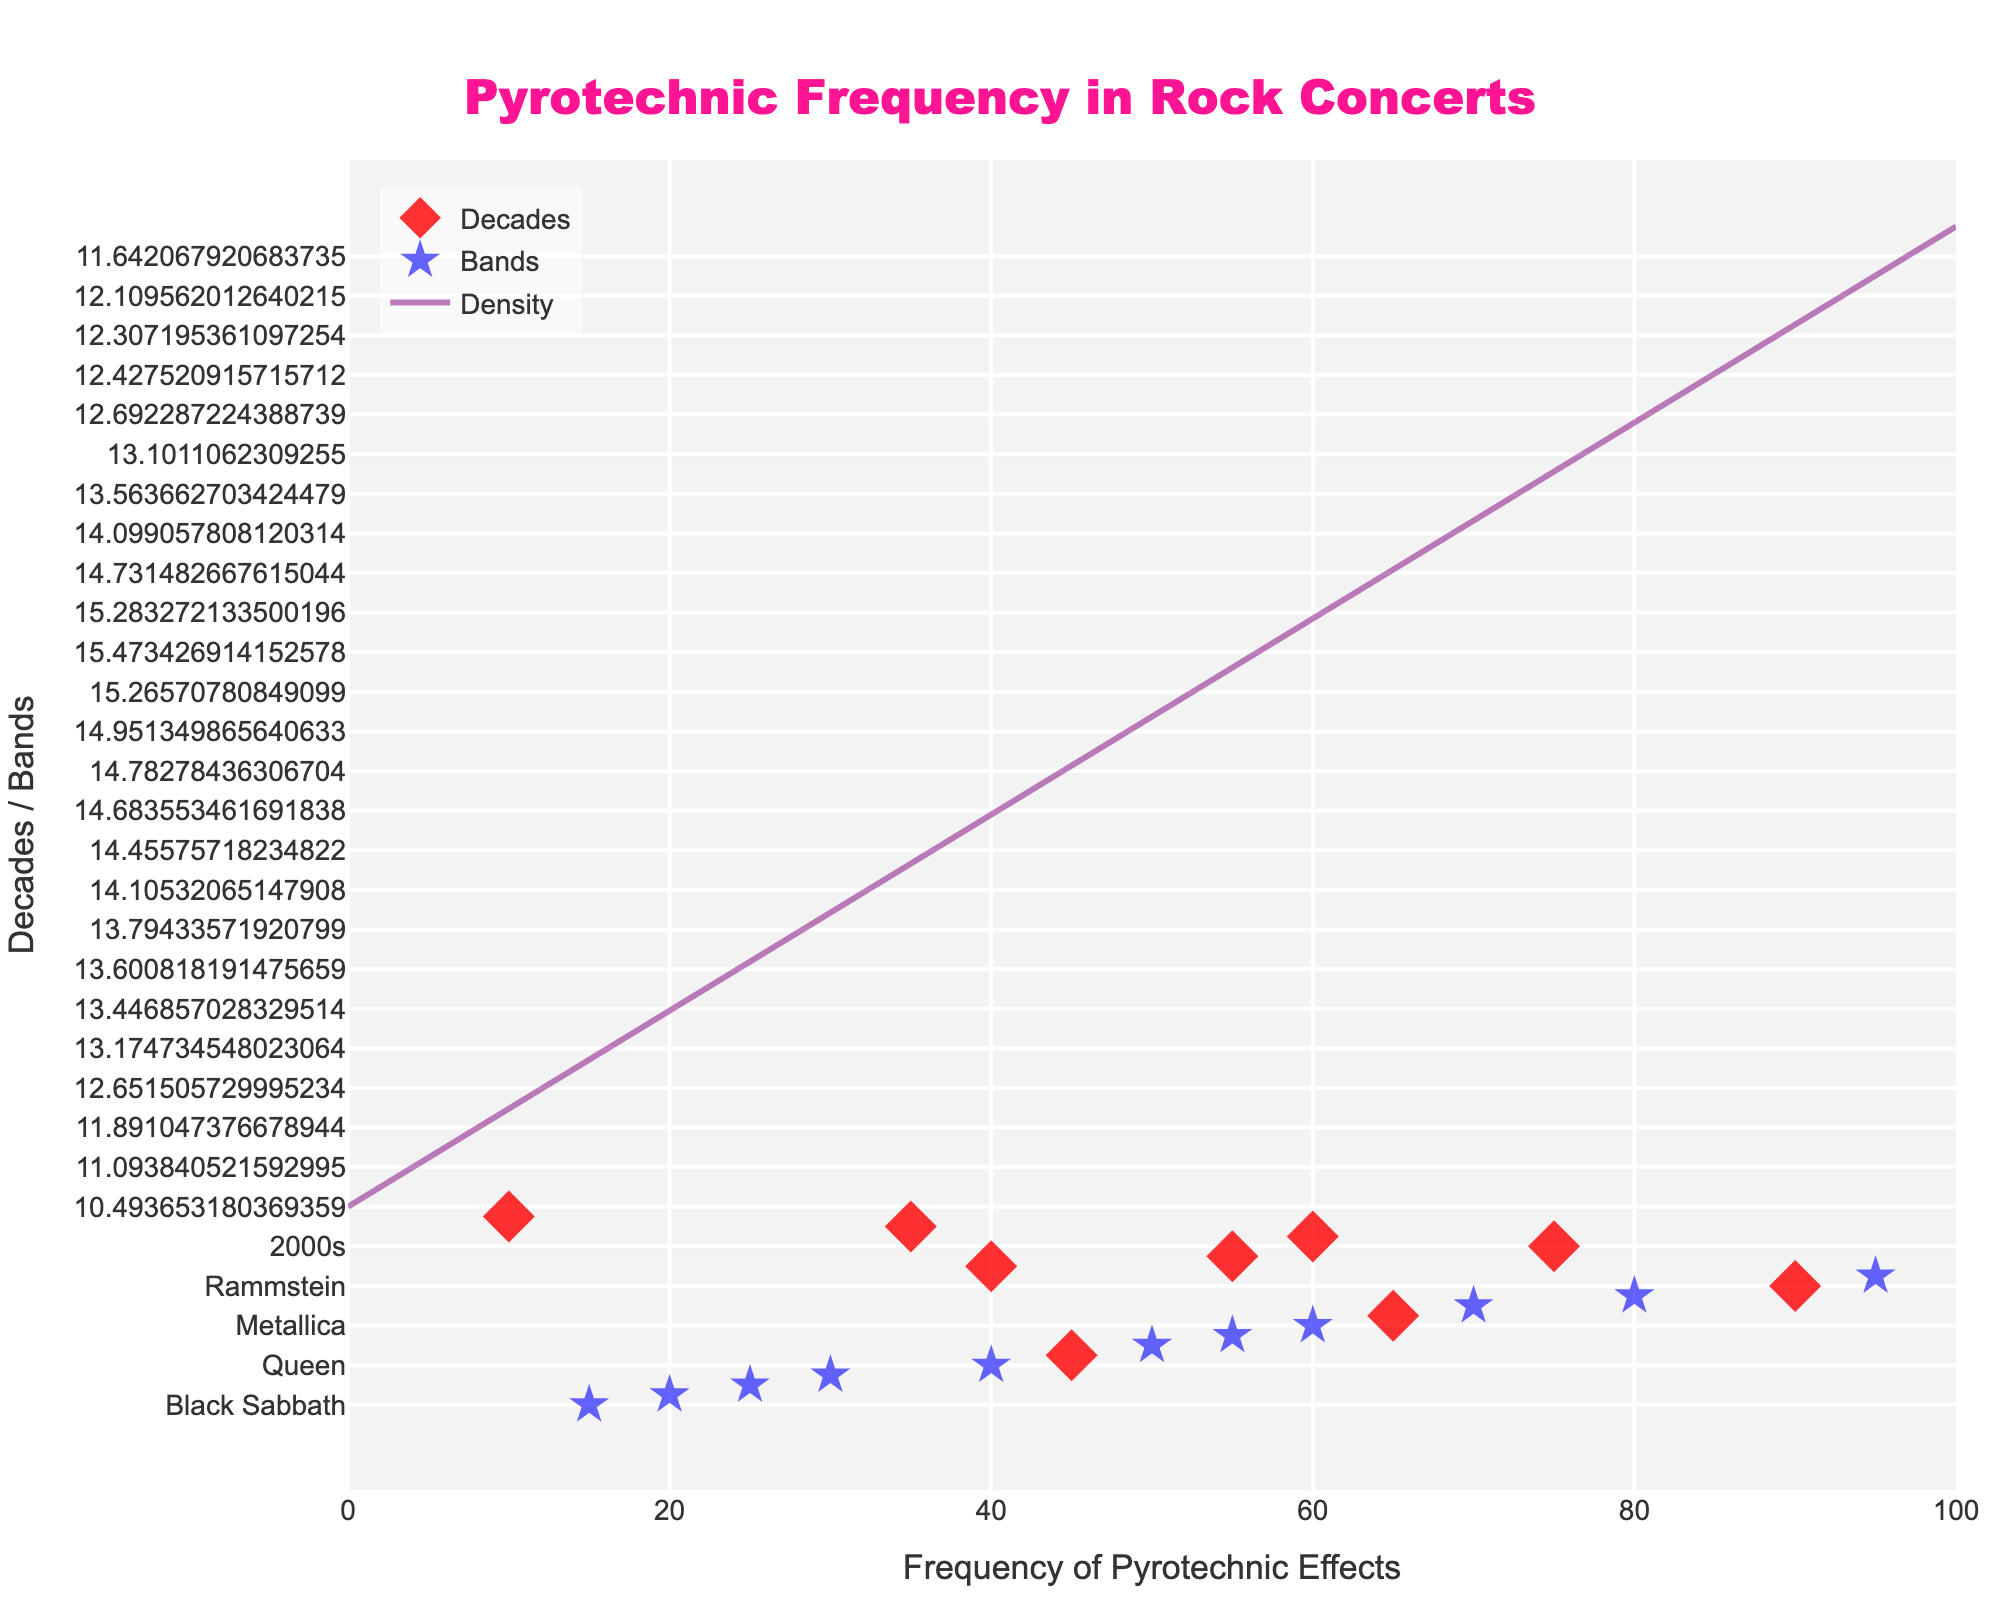What is the title of the figure? The title of the figure is located at the top of the plot. It is formatted in a larger, bold, and colored font so it's easily noticeable.
Answer: Pyrotechnic Frequency in Rock Concerts How many decades are represented in the figure? Count the unique labels on the y-axis, which represent the decades.
Answer: 6 How many bands are marked in the figure? Count the unique labels on the y-axis that are band names, separate from the decades.
Answer: 13 Which decade shows the highest frequency of pyrotechnic effects? Look at the scatter points corresponding to each decade on the y-axis and identify which point is furthest to the right on the x-axis.
Answer: 2000s Which band uses the least pyrotechnic effects? Look at the scatter points corresponding to each band on the y-axis and identify which point is furthest to the left on the x-axis.
Answer: Black Sabbath What is the average pyrotechnic frequency of all bands? Sum the pyrotechnic frequencies of all bands and divide by the number of bands. [(95 + 90 + 80 + 70 + 65 + 60 + 55 + 50 + 45 + 40 + 30 + 25 + 20 + 15) / 13 = 650 / 13 ≈ 50]
Answer: 50 How do the pyrotechnic frequencies of the 1980s and 2020s compare? Look at the x-axis values for the 1980s and 2020s scatter points and determine which is higher. The 1980s have a value of 35 and the 2020s have a value of 40.
Answer: 2020s is higher Which band has a pyrotechnic frequency closest to the overall density peak? Identify where the density curve has its highest value on the x-axis and find the band whose frequency is closest to that peak value. The peak density is around the 60-80 range, and Metallica, with 60, is the closest major band.
Answer: Metallica What is the range of pyrotechnic frequencies among the bands? Identify the minimum and maximum x-axis values for the band scatter points. The minimum is 15 (Black Sabbath) and the maximum is 95 (KISS), so the range is 95 - 15.
Answer: 80 Which band uses pyrotechnic effects more frequently than Iron Maiden but less frequently than Guns N’ Roses? Locate Iron Maiden's frequency (50) and Guns N' Roses' frequency (45) on the x-axis and identify the band that falls between these values (there is no band frequency strictly between these two).
Answer: None 